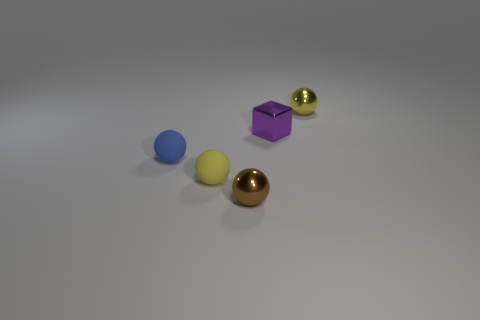What number of large objects are either purple metal things or blue metal cylinders?
Ensure brevity in your answer.  0. There is a small yellow object that is made of the same material as the small purple block; what is its shape?
Make the answer very short. Sphere. Are there fewer purple metallic cubes behind the purple metallic object than big yellow objects?
Offer a terse response. No. Do the small yellow rubber thing and the purple object have the same shape?
Ensure brevity in your answer.  No. How many rubber objects are large brown cylinders or yellow spheres?
Provide a succinct answer. 1. Is there a metal block that has the same size as the brown ball?
Your response must be concise. Yes. How many brown objects have the same size as the blue rubber object?
Your response must be concise. 1. There is a yellow object behind the tiny blue matte ball; is its size the same as the yellow ball to the left of the tiny brown shiny ball?
Your response must be concise. Yes. What number of things are either brown blocks or tiny purple objects right of the small brown thing?
Provide a short and direct response. 1. The small block is what color?
Offer a very short reply. Purple. 